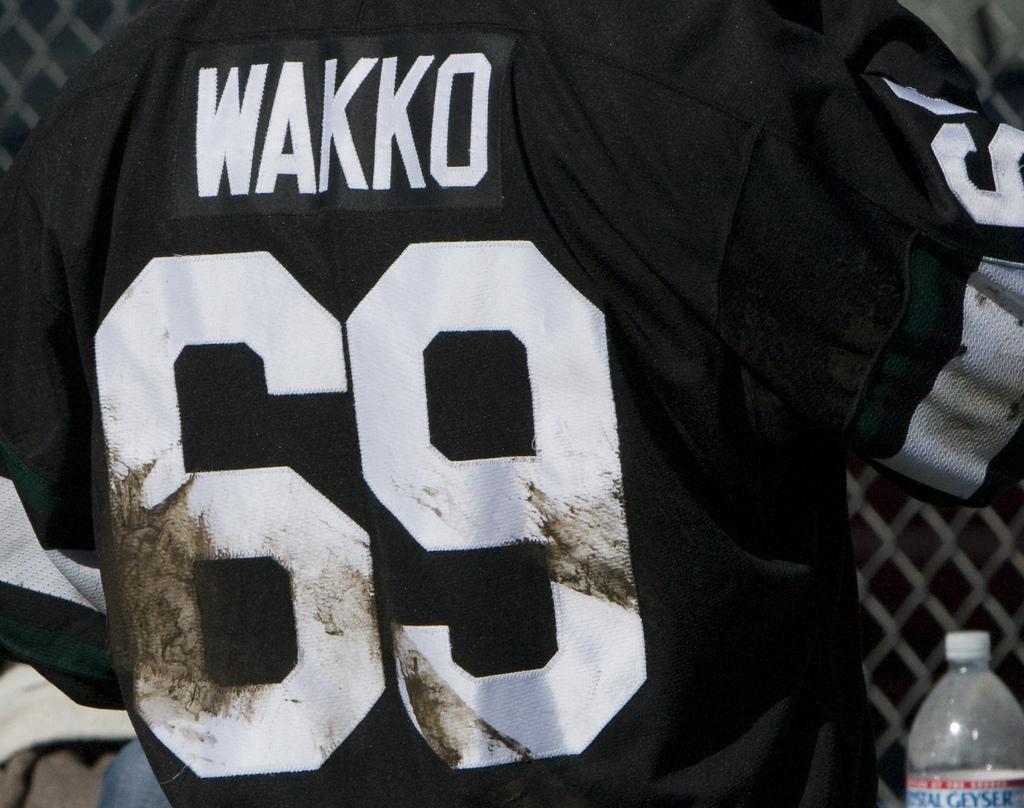What is the player's last name?
Your answer should be very brief. Wakko. What are the numbers under the name?
Your response must be concise. 69. 